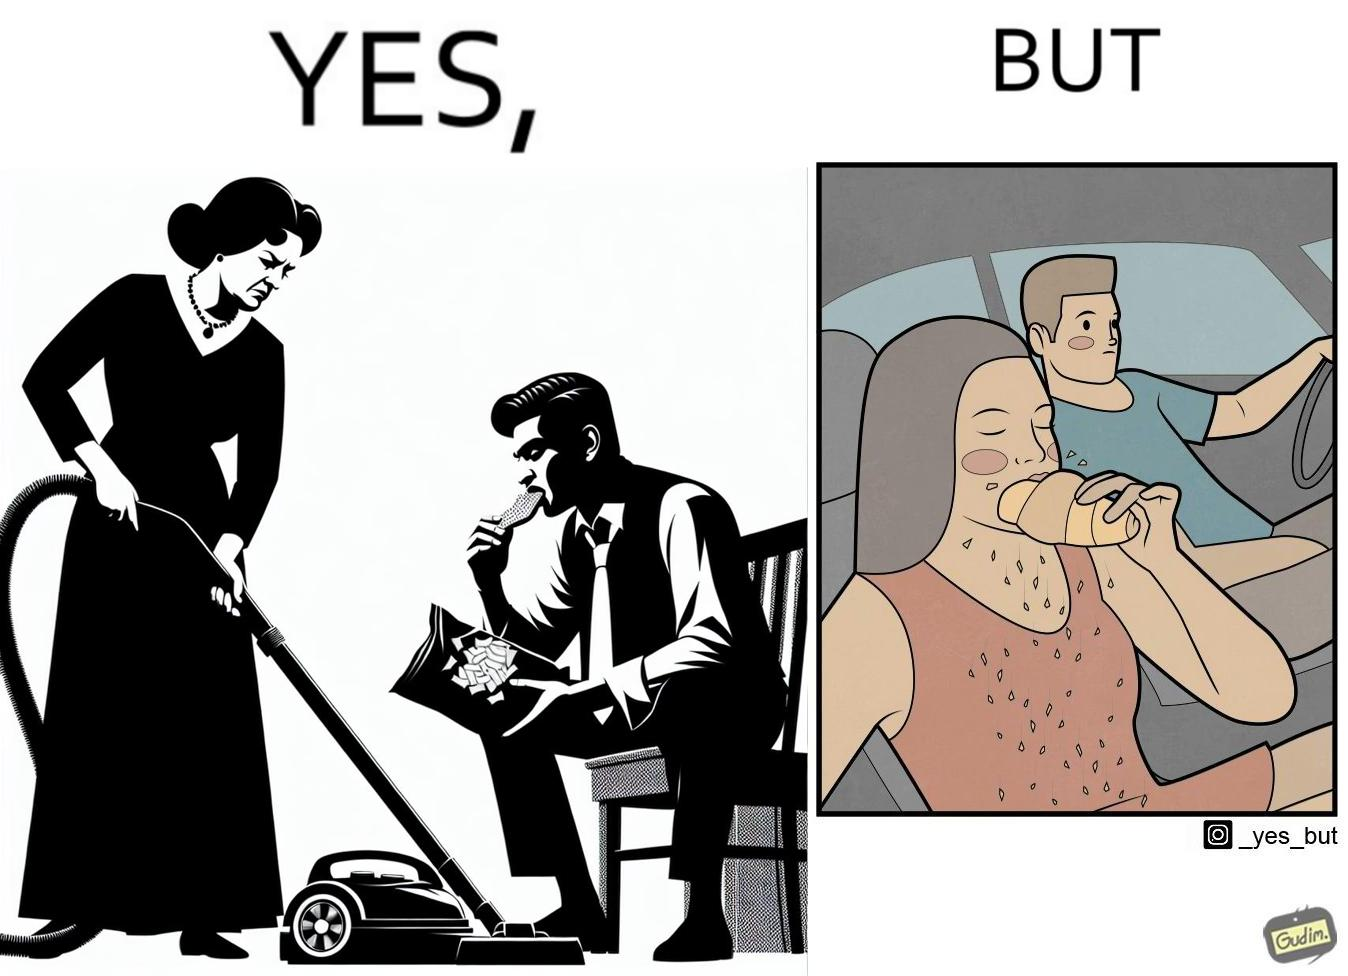Compare the left and right sides of this image. In the left part of the image: a woman cleaning house using vacuum cleaner angrily staring at a man eating chips In the right part of the image: a man looking at the breadcrumbs falling while the woman next to him eating the food while driving car 